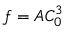<formula> <loc_0><loc_0><loc_500><loc_500>f = A C _ { 0 } ^ { 3 }</formula> 